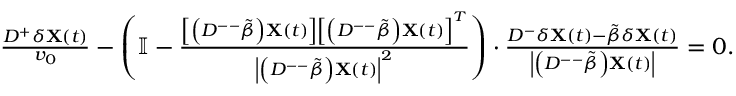<formula> <loc_0><loc_0><loc_500><loc_500>\begin{array} { r } { \frac { D ^ { + } \delta X ( t ) } { v _ { 0 } } - \left ( \mathbb { I } - \frac { \left [ \left ( D ^ { - - } \tilde { \beta } \right ) X ( t ) \right ] \left [ \left ( D ^ { - - } \tilde { \beta } \right ) X ( t ) \right ] ^ { T } } { \left | \left ( D ^ { - - } \tilde { \beta } \right ) X ( t ) \right | ^ { 2 } } \right ) \cdot \frac { D ^ { - } \delta X ( t ) - \tilde { \beta } \delta X ( t ) } { \left | \left ( D ^ { - - } \tilde { \beta } \right ) X ( t ) \right | } = 0 . } \end{array}</formula> 